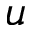Convert formula to latex. <formula><loc_0><loc_0><loc_500><loc_500>u</formula> 